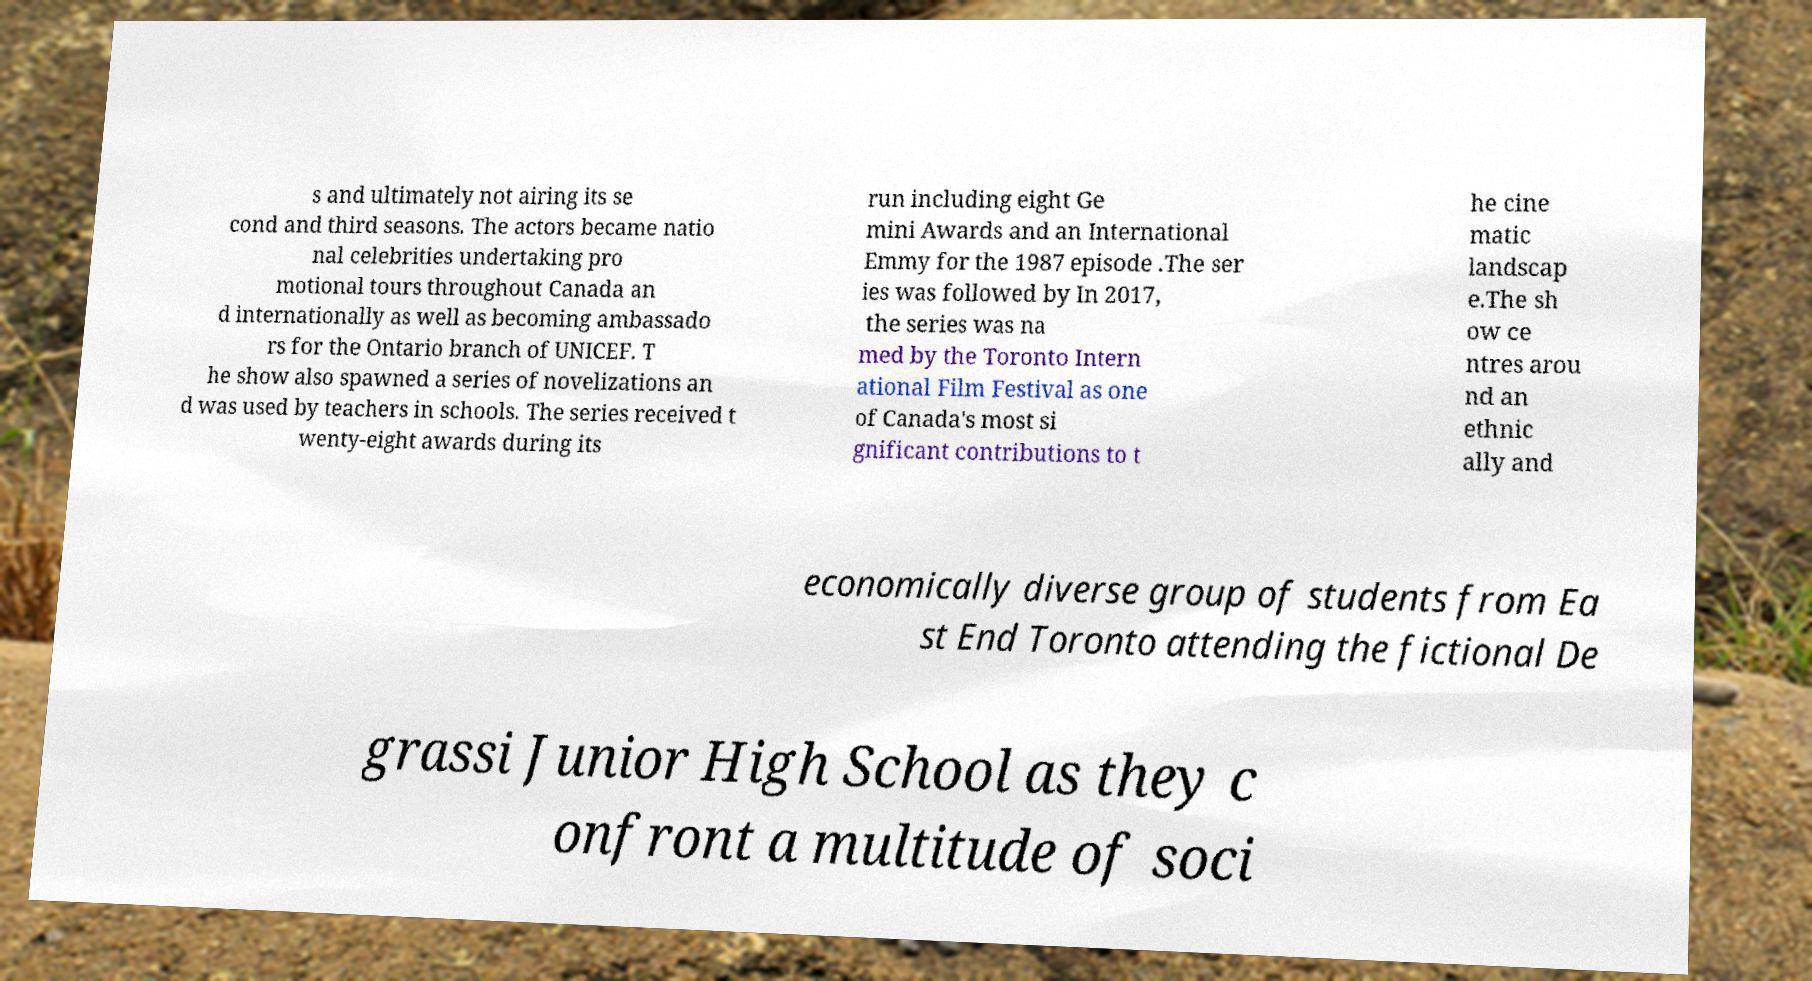What messages or text are displayed in this image? I need them in a readable, typed format. s and ultimately not airing its se cond and third seasons. The actors became natio nal celebrities undertaking pro motional tours throughout Canada an d internationally as well as becoming ambassado rs for the Ontario branch of UNICEF. T he show also spawned a series of novelizations an d was used by teachers in schools. The series received t wenty-eight awards during its run including eight Ge mini Awards and an International Emmy for the 1987 episode .The ser ies was followed by In 2017, the series was na med by the Toronto Intern ational Film Festival as one of Canada's most si gnificant contributions to t he cine matic landscap e.The sh ow ce ntres arou nd an ethnic ally and economically diverse group of students from Ea st End Toronto attending the fictional De grassi Junior High School as they c onfront a multitude of soci 